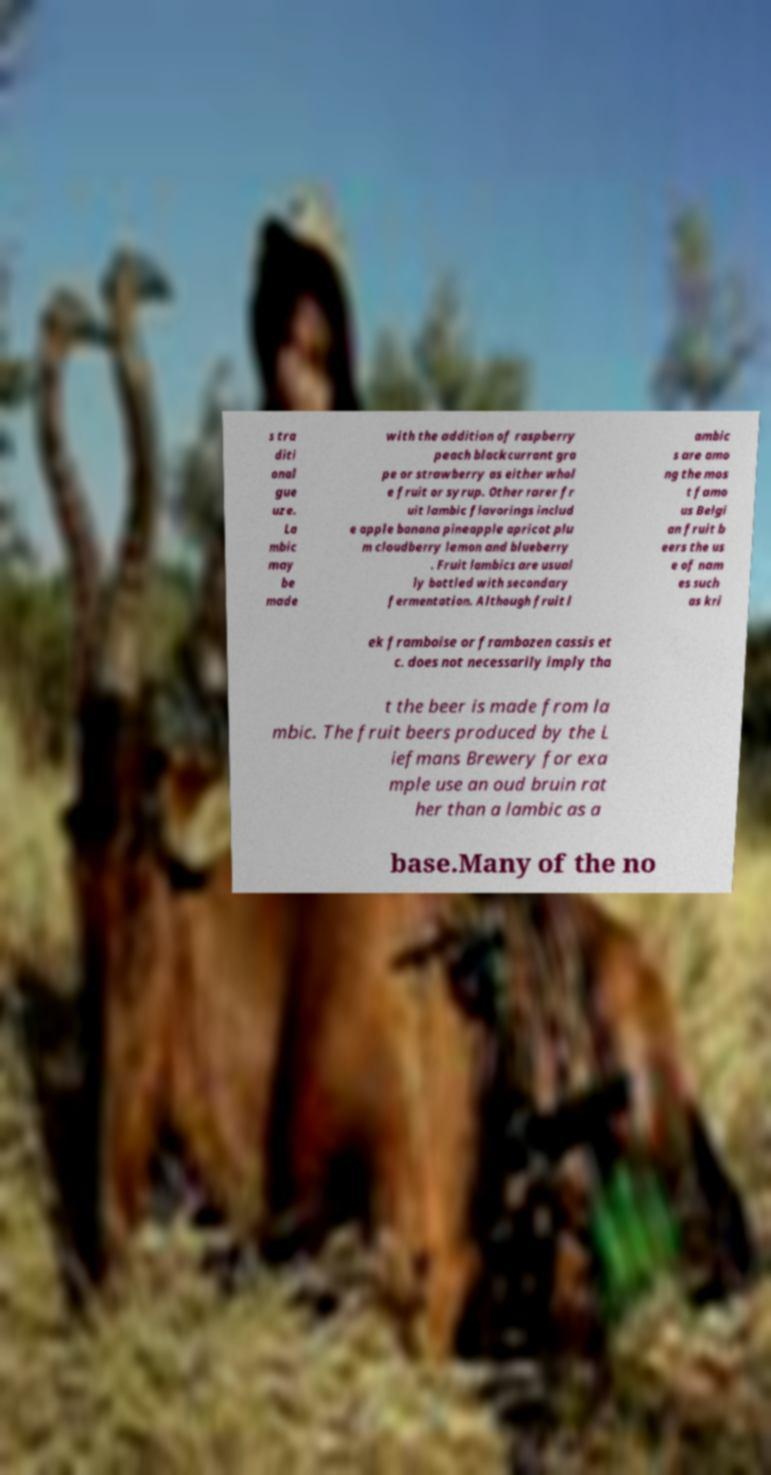I need the written content from this picture converted into text. Can you do that? s tra diti onal gue uze. La mbic may be made with the addition of raspberry peach blackcurrant gra pe or strawberry as either whol e fruit or syrup. Other rarer fr uit lambic flavorings includ e apple banana pineapple apricot plu m cloudberry lemon and blueberry . Fruit lambics are usual ly bottled with secondary fermentation. Although fruit l ambic s are amo ng the mos t famo us Belgi an fruit b eers the us e of nam es such as kri ek framboise or frambozen cassis et c. does not necessarily imply tha t the beer is made from la mbic. The fruit beers produced by the L iefmans Brewery for exa mple use an oud bruin rat her than a lambic as a base.Many of the no 